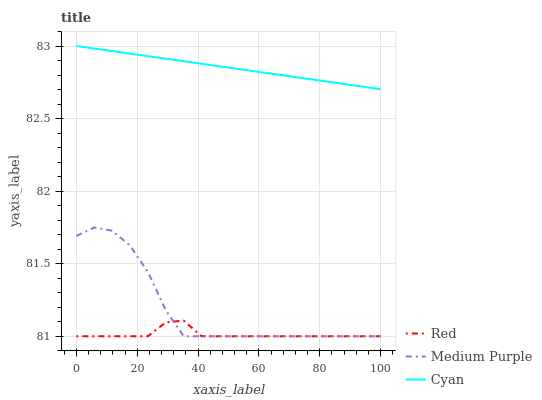Does Red have the minimum area under the curve?
Answer yes or no. Yes. Does Cyan have the maximum area under the curve?
Answer yes or no. Yes. Does Cyan have the minimum area under the curve?
Answer yes or no. No. Does Red have the maximum area under the curve?
Answer yes or no. No. Is Cyan the smoothest?
Answer yes or no. Yes. Is Medium Purple the roughest?
Answer yes or no. Yes. Is Red the smoothest?
Answer yes or no. No. Is Red the roughest?
Answer yes or no. No. Does Medium Purple have the lowest value?
Answer yes or no. Yes. Does Cyan have the lowest value?
Answer yes or no. No. Does Cyan have the highest value?
Answer yes or no. Yes. Does Red have the highest value?
Answer yes or no. No. Is Medium Purple less than Cyan?
Answer yes or no. Yes. Is Cyan greater than Medium Purple?
Answer yes or no. Yes. Does Red intersect Medium Purple?
Answer yes or no. Yes. Is Red less than Medium Purple?
Answer yes or no. No. Is Red greater than Medium Purple?
Answer yes or no. No. Does Medium Purple intersect Cyan?
Answer yes or no. No. 